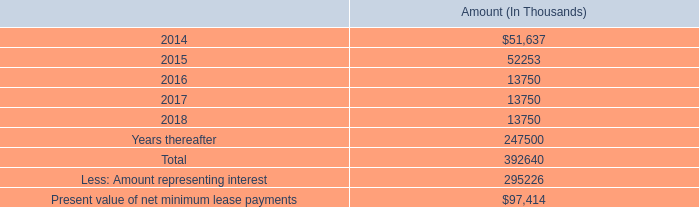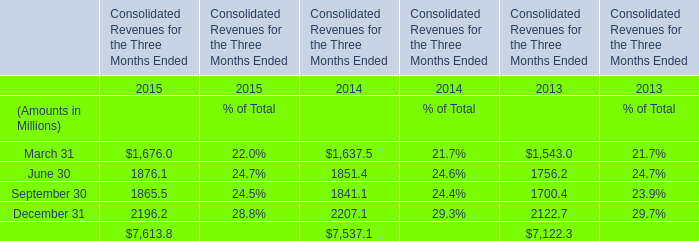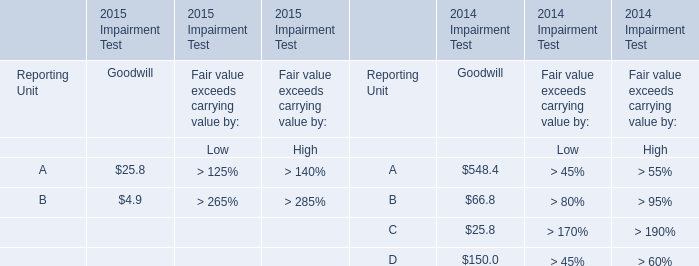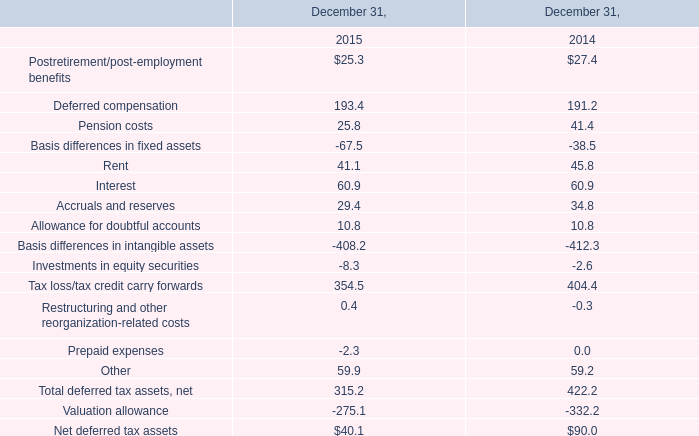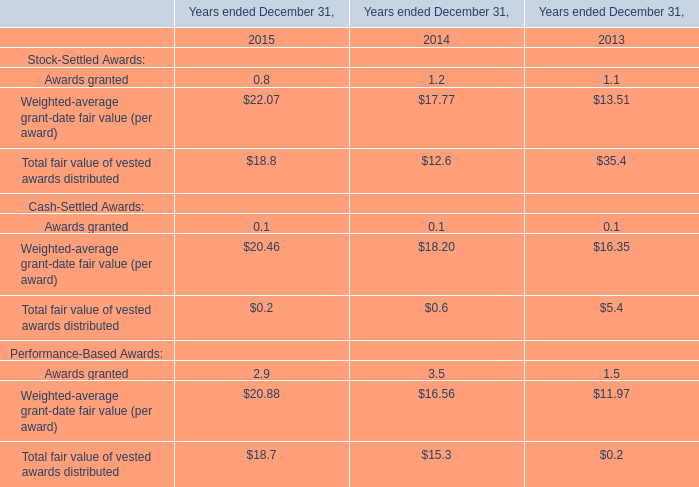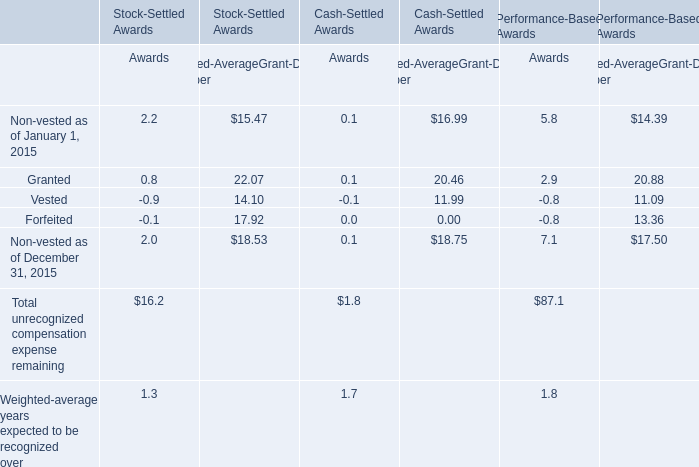How many Vested exceed the average of Vested in 2015? 
Answer: 4. 